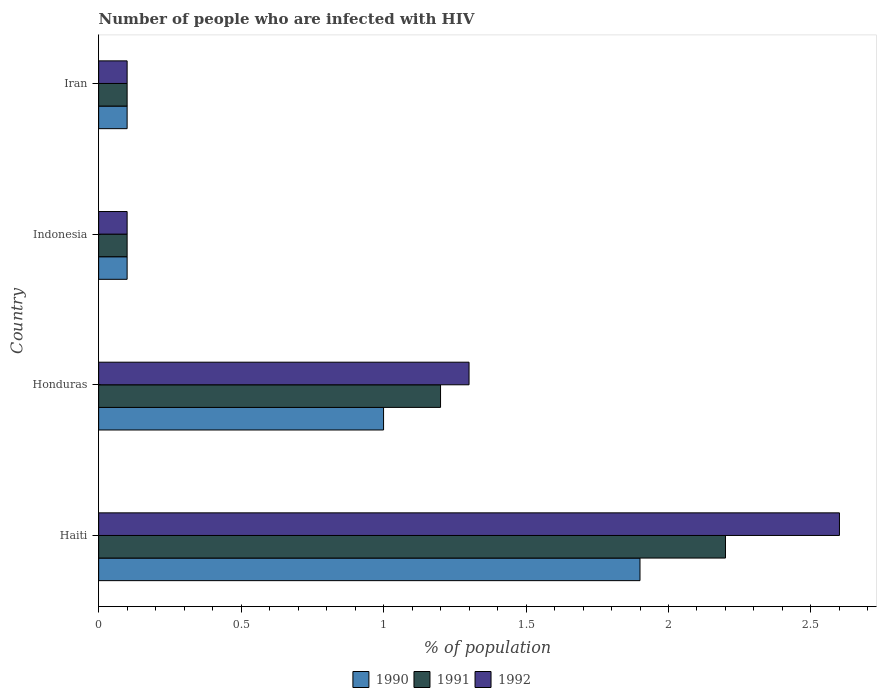How many different coloured bars are there?
Your answer should be compact. 3. Are the number of bars per tick equal to the number of legend labels?
Your answer should be compact. Yes. How many bars are there on the 4th tick from the top?
Offer a terse response. 3. In how many cases, is the number of bars for a given country not equal to the number of legend labels?
Offer a terse response. 0. What is the percentage of HIV infected population in in 1991 in Honduras?
Keep it short and to the point. 1.2. Across all countries, what is the maximum percentage of HIV infected population in in 1990?
Offer a very short reply. 1.9. Across all countries, what is the minimum percentage of HIV infected population in in 1991?
Your answer should be very brief. 0.1. In which country was the percentage of HIV infected population in in 1990 maximum?
Offer a terse response. Haiti. What is the total percentage of HIV infected population in in 1991 in the graph?
Your response must be concise. 3.6. What is the difference between the percentage of HIV infected population in in 1991 in Haiti and the percentage of HIV infected population in in 1990 in Indonesia?
Ensure brevity in your answer.  2.1. What is the difference between the percentage of HIV infected population in in 1990 and percentage of HIV infected population in in 1991 in Haiti?
Provide a succinct answer. -0.3. In how many countries, is the percentage of HIV infected population in in 1991 greater than 2.6 %?
Give a very brief answer. 0. What is the ratio of the percentage of HIV infected population in in 1990 in Haiti to that in Iran?
Your answer should be very brief. 19. What is the difference between the highest and the second highest percentage of HIV infected population in in 1991?
Your answer should be very brief. 1. What is the difference between the highest and the lowest percentage of HIV infected population in in 1992?
Give a very brief answer. 2.5. In how many countries, is the percentage of HIV infected population in in 1990 greater than the average percentage of HIV infected population in in 1990 taken over all countries?
Your answer should be compact. 2. What does the 3rd bar from the top in Indonesia represents?
Your answer should be very brief. 1990. What does the 2nd bar from the bottom in Iran represents?
Your answer should be compact. 1991. Are all the bars in the graph horizontal?
Make the answer very short. Yes. What is the difference between two consecutive major ticks on the X-axis?
Your answer should be very brief. 0.5. How are the legend labels stacked?
Your answer should be very brief. Horizontal. What is the title of the graph?
Your answer should be very brief. Number of people who are infected with HIV. Does "1971" appear as one of the legend labels in the graph?
Make the answer very short. No. What is the label or title of the X-axis?
Your answer should be compact. % of population. What is the % of population in 1991 in Haiti?
Your response must be concise. 2.2. What is the % of population in 1992 in Haiti?
Ensure brevity in your answer.  2.6. What is the % of population in 1990 in Honduras?
Your response must be concise. 1. What is the % of population in 1991 in Honduras?
Your answer should be very brief. 1.2. What is the % of population in 1992 in Honduras?
Your answer should be compact. 1.3. Across all countries, what is the maximum % of population in 1990?
Offer a terse response. 1.9. Across all countries, what is the maximum % of population of 1991?
Keep it short and to the point. 2.2. Across all countries, what is the maximum % of population of 1992?
Provide a succinct answer. 2.6. Across all countries, what is the minimum % of population of 1992?
Give a very brief answer. 0.1. What is the total % of population in 1990 in the graph?
Keep it short and to the point. 3.1. What is the total % of population in 1991 in the graph?
Give a very brief answer. 3.6. What is the difference between the % of population in 1990 in Haiti and that in Honduras?
Offer a very short reply. 0.9. What is the difference between the % of population in 1991 in Haiti and that in Indonesia?
Offer a terse response. 2.1. What is the difference between the % of population of 1992 in Haiti and that in Indonesia?
Your answer should be compact. 2.5. What is the difference between the % of population in 1990 in Haiti and that in Iran?
Offer a terse response. 1.8. What is the difference between the % of population of 1992 in Haiti and that in Iran?
Offer a very short reply. 2.5. What is the difference between the % of population in 1990 in Honduras and that in Indonesia?
Your answer should be very brief. 0.9. What is the difference between the % of population in 1992 in Honduras and that in Indonesia?
Provide a succinct answer. 1.2. What is the difference between the % of population of 1990 in Honduras and that in Iran?
Provide a succinct answer. 0.9. What is the difference between the % of population in 1991 in Honduras and that in Iran?
Your answer should be compact. 1.1. What is the difference between the % of population in 1990 in Haiti and the % of population in 1992 in Honduras?
Your response must be concise. 0.6. What is the difference between the % of population in 1991 in Haiti and the % of population in 1992 in Iran?
Keep it short and to the point. 2.1. What is the difference between the % of population in 1991 in Honduras and the % of population in 1992 in Indonesia?
Ensure brevity in your answer.  1.1. What is the difference between the % of population in 1990 in Honduras and the % of population in 1992 in Iran?
Provide a succinct answer. 0.9. What is the difference between the % of population in 1991 in Honduras and the % of population in 1992 in Iran?
Make the answer very short. 1.1. What is the difference between the % of population in 1990 in Indonesia and the % of population in 1992 in Iran?
Provide a short and direct response. 0. What is the difference between the % of population in 1991 in Indonesia and the % of population in 1992 in Iran?
Your answer should be compact. 0. What is the average % of population of 1990 per country?
Provide a succinct answer. 0.78. What is the average % of population of 1992 per country?
Make the answer very short. 1.02. What is the difference between the % of population of 1991 and % of population of 1992 in Haiti?
Make the answer very short. -0.4. What is the difference between the % of population of 1990 and % of population of 1991 in Indonesia?
Make the answer very short. 0. What is the difference between the % of population of 1990 and % of population of 1992 in Iran?
Your response must be concise. 0. What is the difference between the % of population in 1991 and % of population in 1992 in Iran?
Keep it short and to the point. 0. What is the ratio of the % of population in 1990 in Haiti to that in Honduras?
Offer a very short reply. 1.9. What is the ratio of the % of population in 1991 in Haiti to that in Honduras?
Provide a succinct answer. 1.83. What is the ratio of the % of population of 1991 in Haiti to that in Indonesia?
Offer a very short reply. 22. What is the ratio of the % of population of 1992 in Haiti to that in Indonesia?
Your answer should be very brief. 26. What is the ratio of the % of population in 1990 in Haiti to that in Iran?
Provide a succinct answer. 19. What is the ratio of the % of population in 1991 in Haiti to that in Iran?
Ensure brevity in your answer.  22. What is the ratio of the % of population of 1991 in Honduras to that in Indonesia?
Ensure brevity in your answer.  12. What is the ratio of the % of population of 1991 in Honduras to that in Iran?
Make the answer very short. 12. What is the ratio of the % of population of 1991 in Indonesia to that in Iran?
Provide a succinct answer. 1. What is the difference between the highest and the second highest % of population of 1990?
Ensure brevity in your answer.  0.9. What is the difference between the highest and the second highest % of population in 1992?
Ensure brevity in your answer.  1.3. What is the difference between the highest and the lowest % of population in 1990?
Offer a terse response. 1.8. What is the difference between the highest and the lowest % of population in 1992?
Your answer should be very brief. 2.5. 